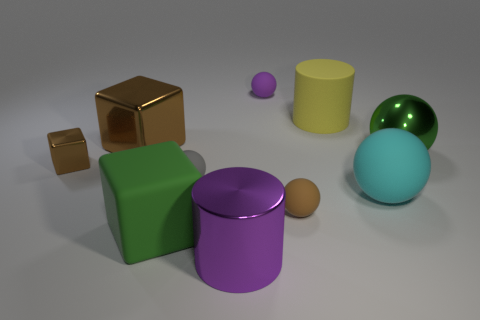There is a big thing that is the same color as the tiny shiny block; what shape is it?
Provide a succinct answer. Cube. Does the brown matte object have the same size as the purple object behind the green rubber cube?
Offer a terse response. Yes. How many small purple balls are in front of the brown block that is in front of the large green object that is behind the brown sphere?
Provide a short and direct response. 0. There is a sphere that is the same color as the shiny cylinder; what is its size?
Offer a terse response. Small. Are there any gray rubber spheres to the right of the small gray matte sphere?
Offer a terse response. No. What is the shape of the tiny purple matte object?
Your answer should be compact. Sphere. What shape is the green object that is left of the big purple metal cylinder that is to the right of the brown block that is behind the big shiny sphere?
Your answer should be very brief. Cube. How many other objects are there of the same shape as the gray rubber object?
Your answer should be very brief. 4. What material is the big cylinder that is left of the tiny rubber thing behind the green metal thing?
Your response must be concise. Metal. Is the material of the tiny gray object the same as the purple thing that is in front of the large cyan matte object?
Your answer should be very brief. No. 